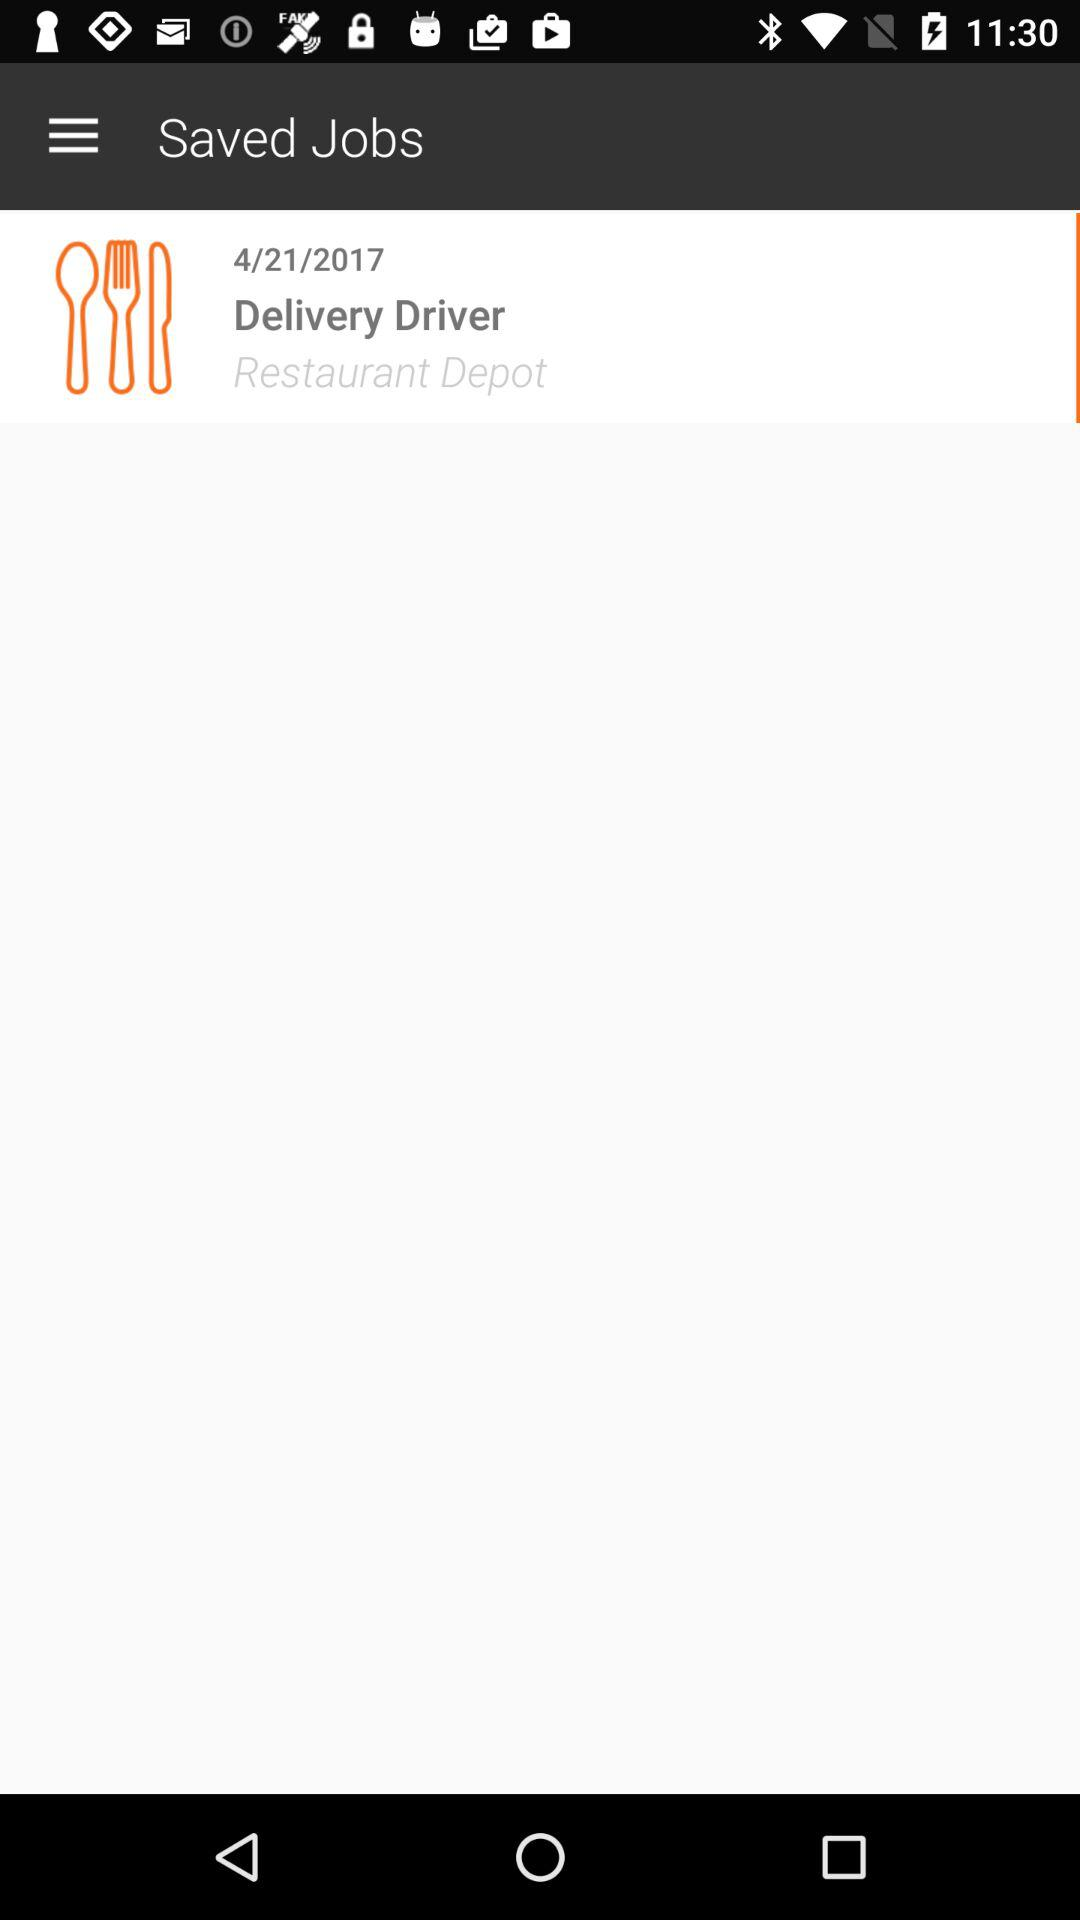What is the saved job name? The saved job name is delivery driver. 